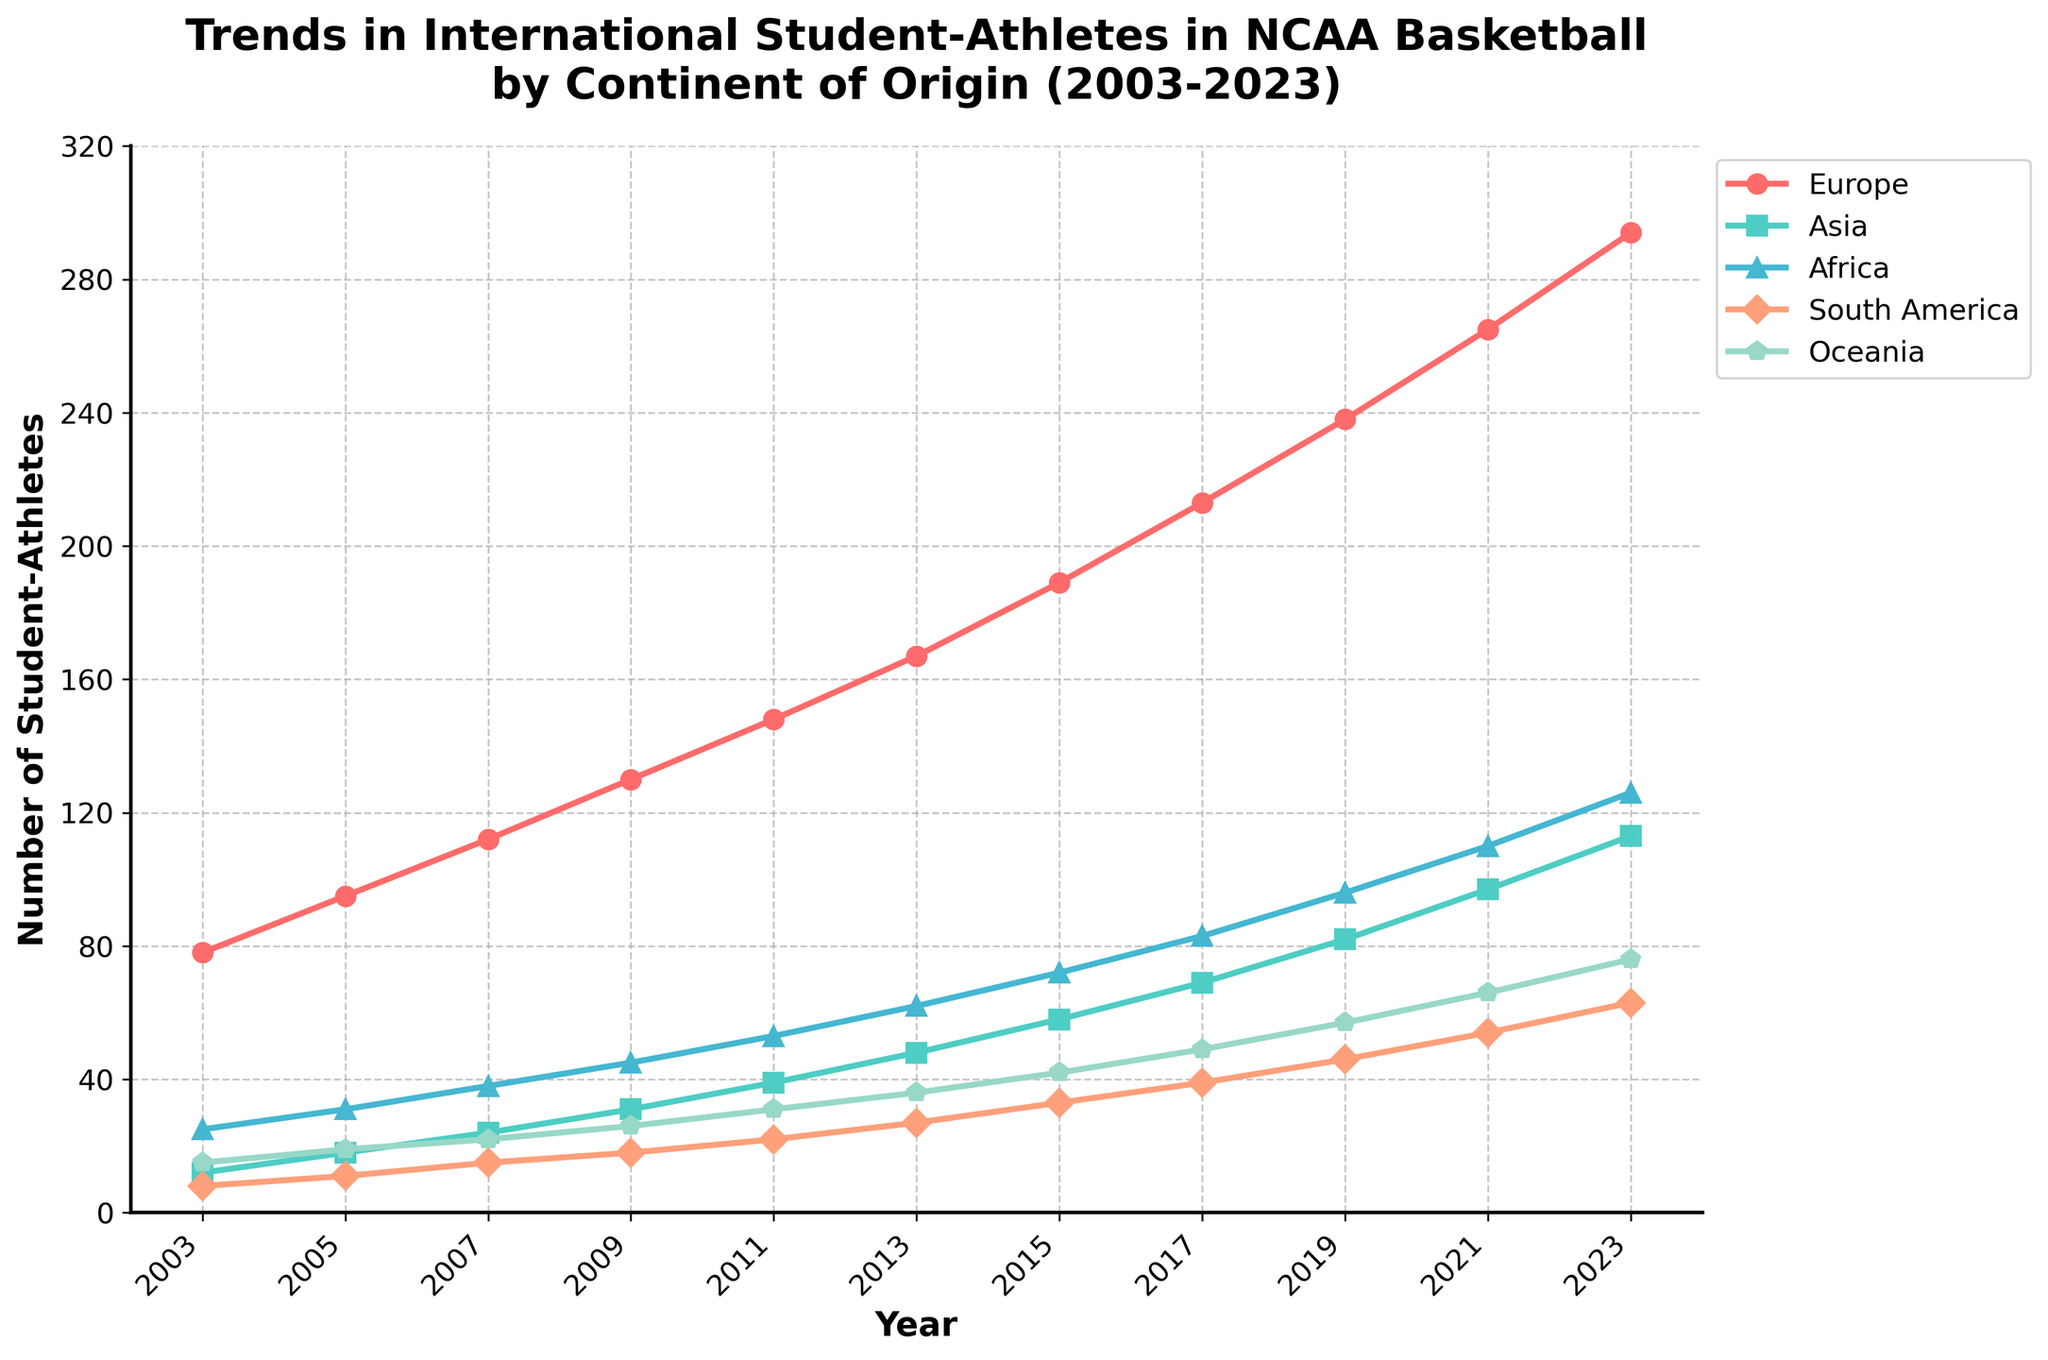What continent experienced the highest growth in the number of student-athletes between 2003 and 2023? To find this, look at the figures for each continent in 2003 and 2023, then calculate the difference for each. Europe grew from 78 to 294, Asia from 12 to 113, Africa from 25 to 126, South America from 8 to 63, Oceania from 15 to 76. Europe had the highest growth (294 - 78) = 216.
Answer: Europe Which year had the highest number of student-athletes from Asia? Look at the trend line associated with Asia (green) and identify the peak point. The highest value for Asia is in 2023, which is 113.
Answer: 2023 How many more student-athletes were there from Africa than from Oceania in 2023? Find the difference between the 2023 figures for Africa and Oceania. Africa had 126 student-athletes and Oceania had 76. So 126 - 76 = 50.
Answer: 50 What is the total number of international student-athletes from all continents in 2019? Sum the number of student-athletes from each continent in 2019. 238 (Europe) + 82 (Asia) + 96 (Africa) + 46 (South America) + 57 (Oceania) = 519.
Answer: 519 Which continent showed the least growth in the number of student-athletes from 2003 to 2023? Calculate the growth for each continent: Europe (294-78), Asia (113-12), Africa (126-25), South America (63-8), Oceania (76-15). South America had the smallest increase (63 - 8) = 55.
Answer: South America Between which two consecutive years did Europe see the greatest increase in the number of student-athletes? Look at the Europe trend and find the greatest jump between two consecutive years. The biggest increase for Europe is from 2019 to 2021 (265 - 238) = 27.
Answer: 2019 to 2021 In which year was the number of student-athletes from Africa equal to the number of student-athletes from South America? Compare the trends for Africa and South America to find any common values. Both Africa and South America had 18 student-athletes in 2009.
Answer: 2009 What is the average number of student-athletes from Oceania over the years 2003 to 2023? Calculate the average by summing Oceania values and dividing by the number of years. The sum is 15+19+22+26+31+36+42+49+57+66+76 = 439. There are 11 data points, so the average is 439/11 ≈ 39.91.
Answer: 39.91 By how much did the number of student-athletes from South America increase from 2003 to 2023? Subtract the 2003 value from the 2023 value for South America. 2023 had 63 and 2003 had 8, so 63 - 8 = 55.
Answer: 55 In which year did Africa surpass 50 student-athletes for the first time? Observe the values for Africa and identify the first year it exceeds 50. Africa had 53 student-athletes in 2011.
Answer: 2011 